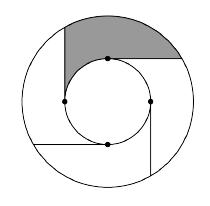Can you explain why the rays are tangent and do not intersect inside the smaller circle? The rays drawn from points on the smaller circle to the larger circle are purposely tangent to not only minimize the area but also ensure each section between the rays remains distinct and symmetrical. By mathematical principle, a tangent at any point on a circle meets perpendicular to the radius at that point, preventing any two tangents from intersecting within the circle they touch. The geometry here ensures that every ray touches the smaller circle precisely without crossing inside it, creating clear, non-overlapping paths to the larger circle. 